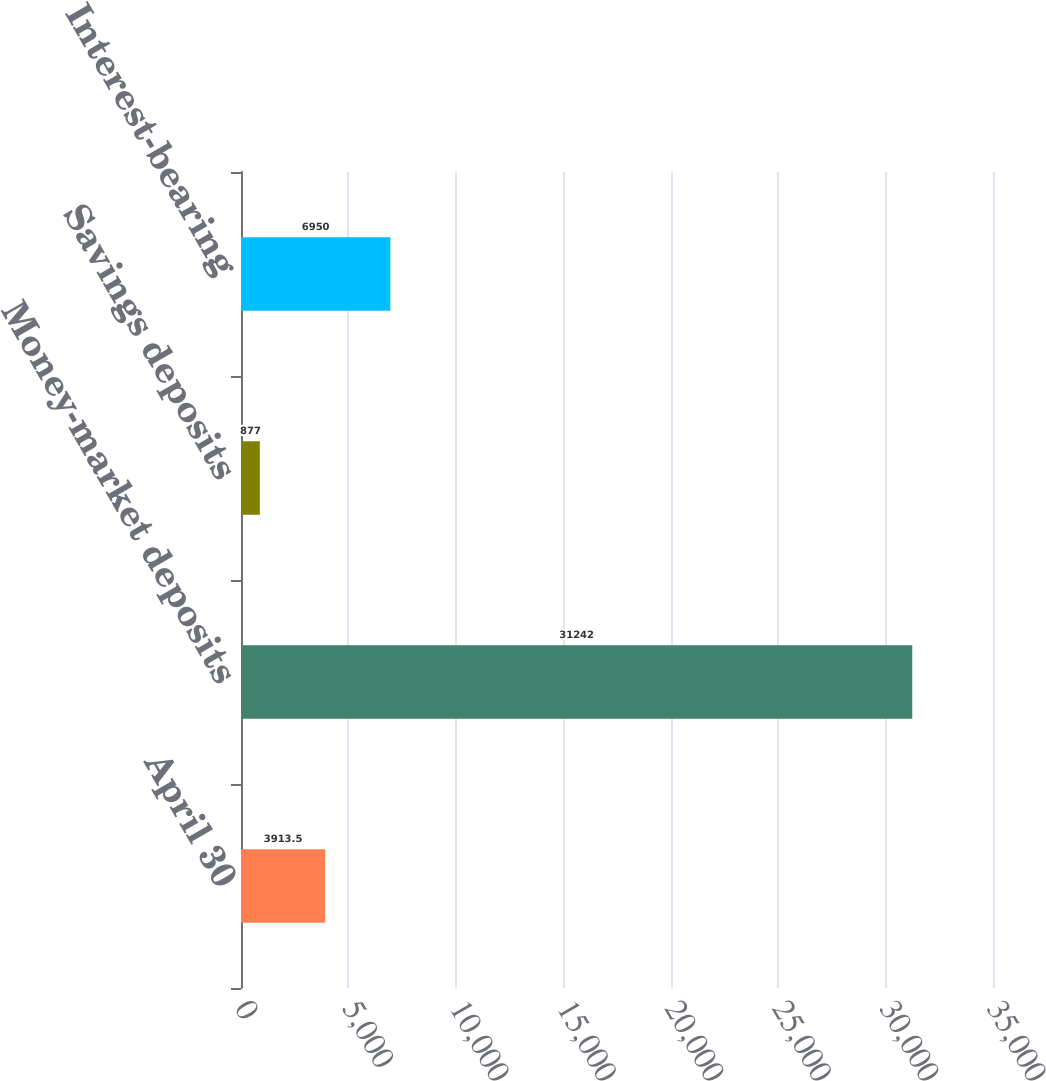Convert chart. <chart><loc_0><loc_0><loc_500><loc_500><bar_chart><fcel>April 30<fcel>Money-market deposits<fcel>Savings deposits<fcel>Interest-bearing<nl><fcel>3913.5<fcel>31242<fcel>877<fcel>6950<nl></chart> 